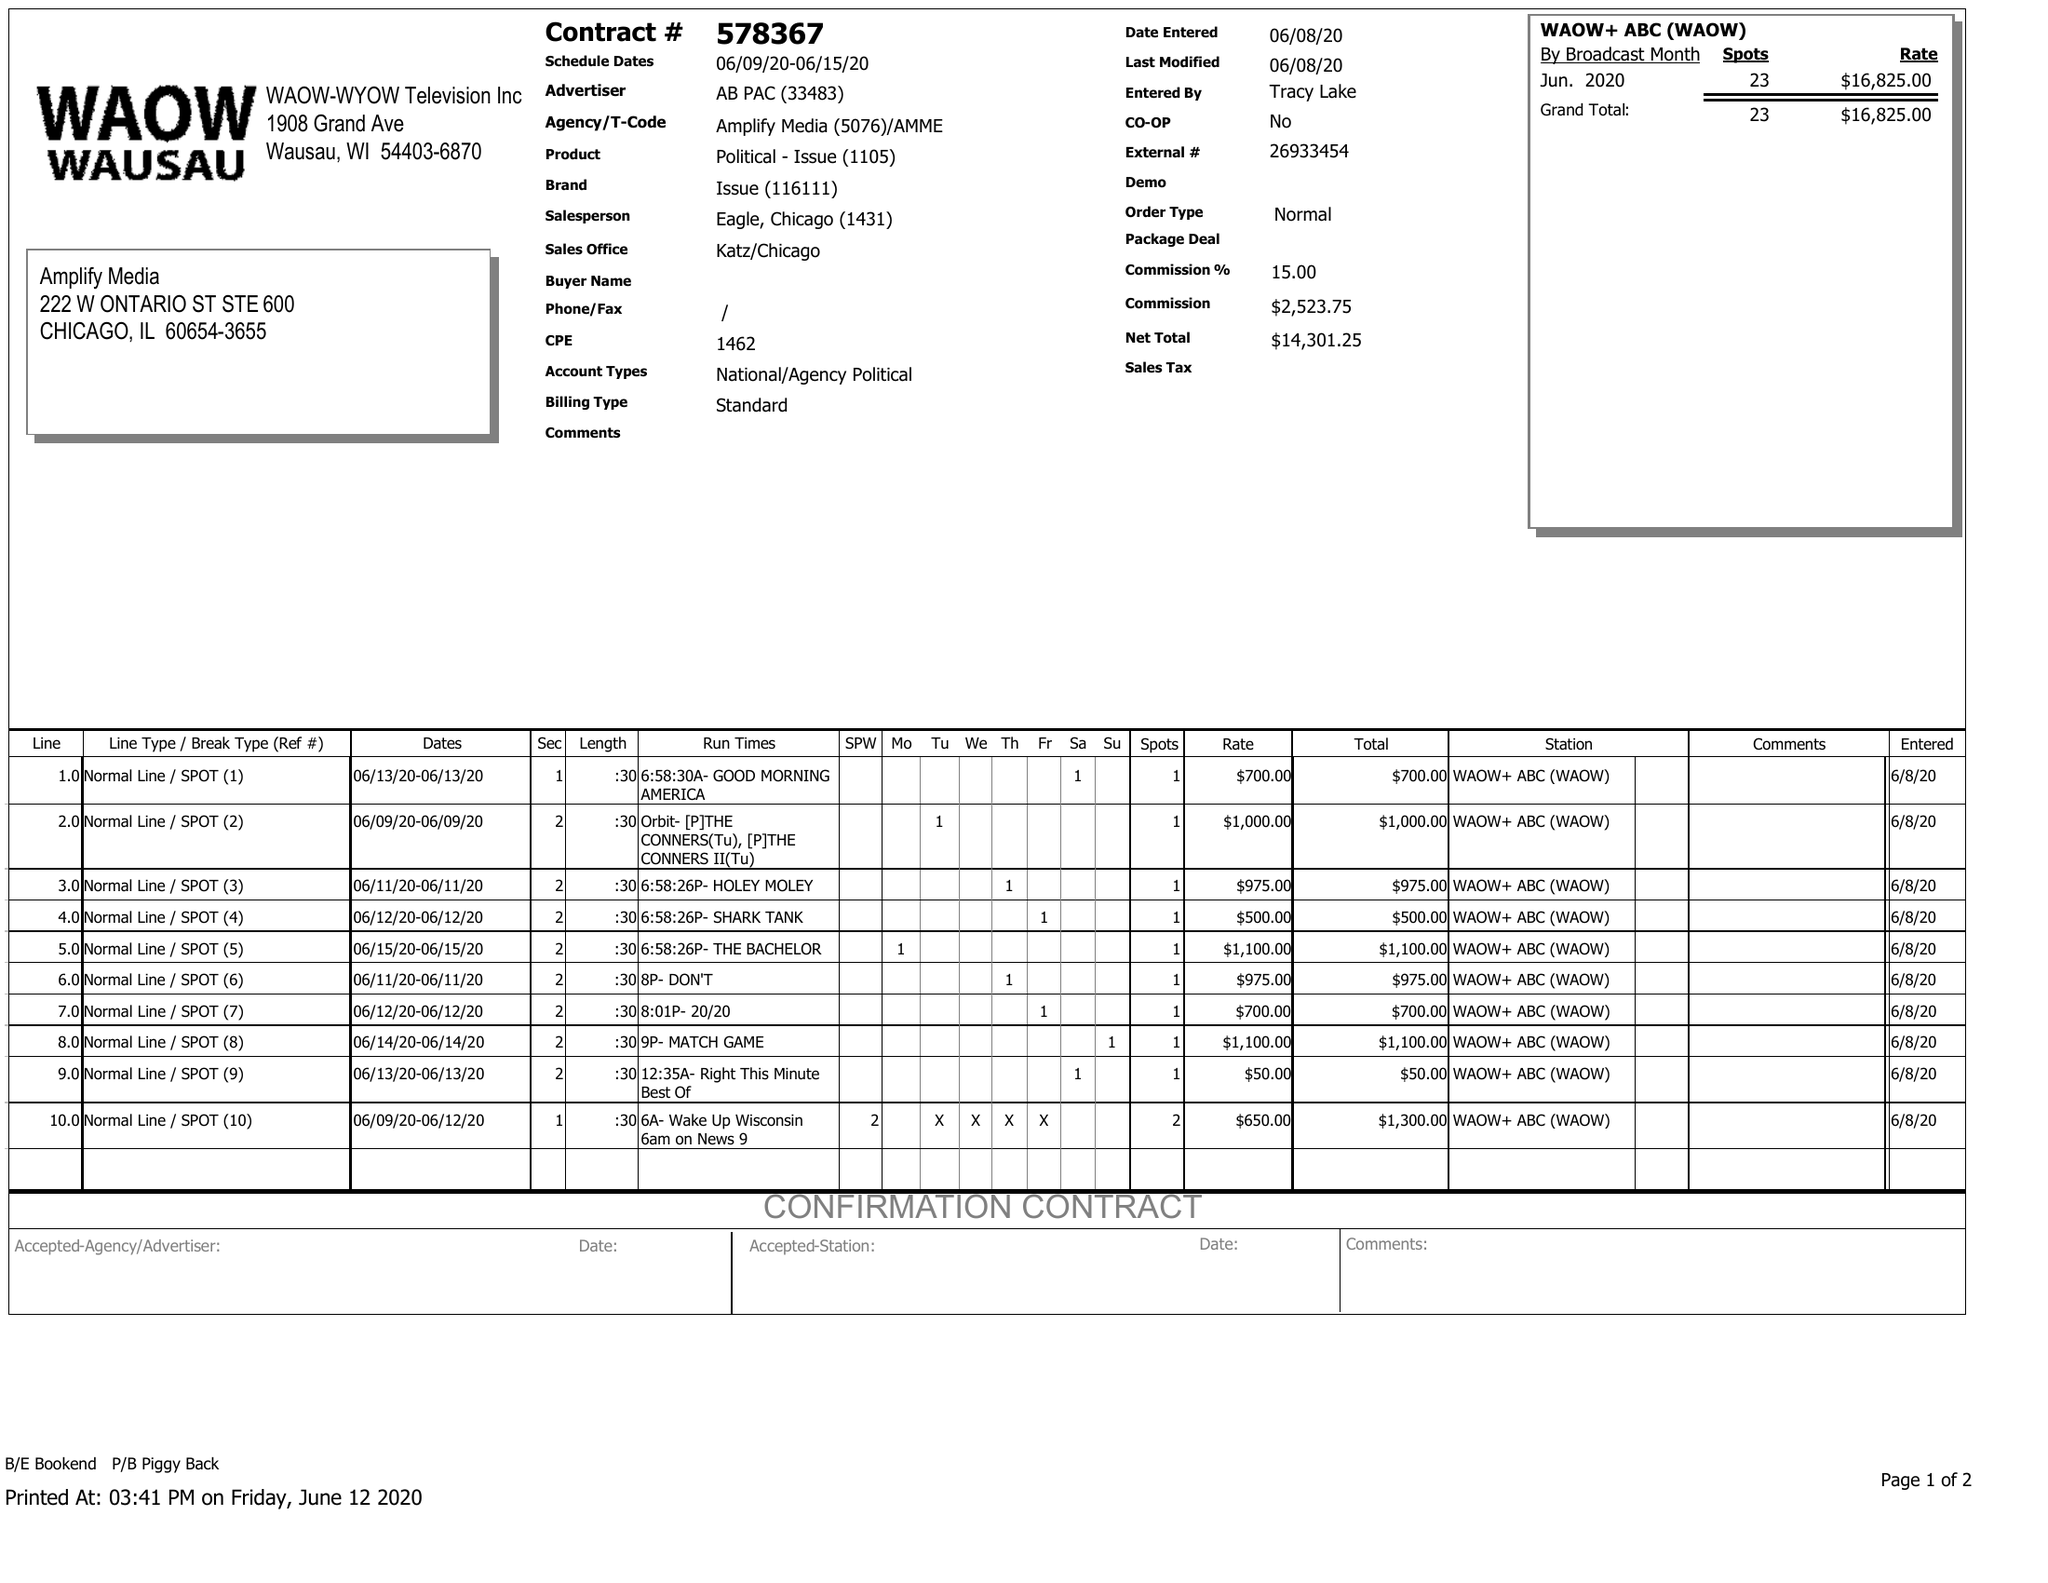What is the value for the flight_to?
Answer the question using a single word or phrase. 06/15/20 